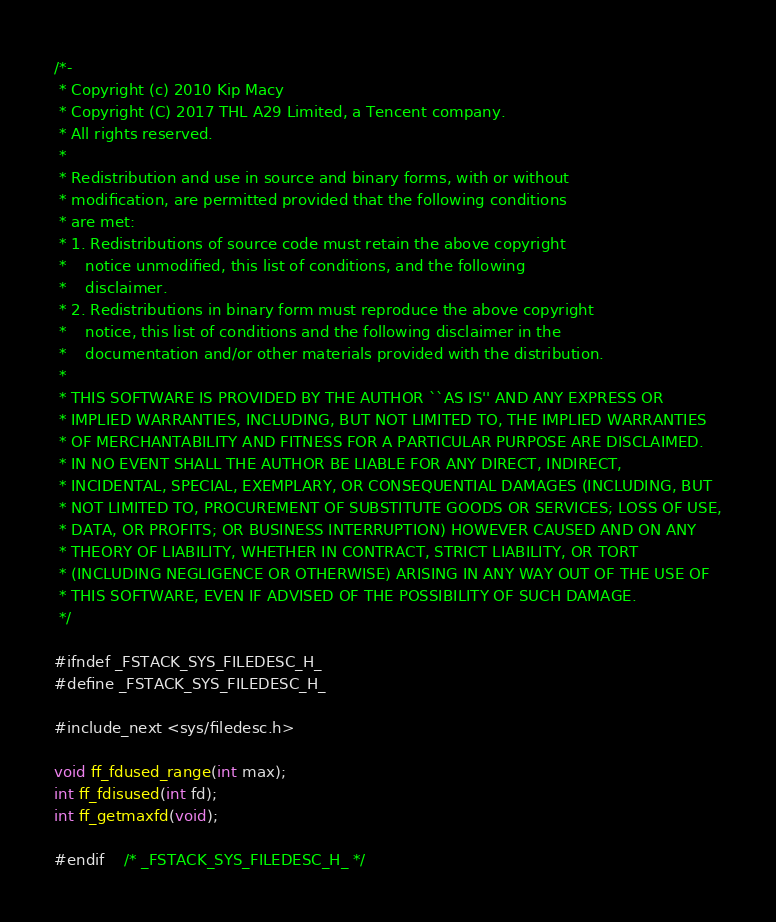Convert code to text. <code><loc_0><loc_0><loc_500><loc_500><_C_>/*-
 * Copyright (c) 2010 Kip Macy
 * Copyright (C) 2017 THL A29 Limited, a Tencent company.
 * All rights reserved.
 *
 * Redistribution and use in source and binary forms, with or without
 * modification, are permitted provided that the following conditions
 * are met:
 * 1. Redistributions of source code must retain the above copyright
 *    notice unmodified, this list of conditions, and the following
 *    disclaimer.
 * 2. Redistributions in binary form must reproduce the above copyright
 *    notice, this list of conditions and the following disclaimer in the
 *    documentation and/or other materials provided with the distribution.
 *
 * THIS SOFTWARE IS PROVIDED BY THE AUTHOR ``AS IS'' AND ANY EXPRESS OR
 * IMPLIED WARRANTIES, INCLUDING, BUT NOT LIMITED TO, THE IMPLIED WARRANTIES
 * OF MERCHANTABILITY AND FITNESS FOR A PARTICULAR PURPOSE ARE DISCLAIMED.
 * IN NO EVENT SHALL THE AUTHOR BE LIABLE FOR ANY DIRECT, INDIRECT,
 * INCIDENTAL, SPECIAL, EXEMPLARY, OR CONSEQUENTIAL DAMAGES (INCLUDING, BUT
 * NOT LIMITED TO, PROCUREMENT OF SUBSTITUTE GOODS OR SERVICES; LOSS OF USE,
 * DATA, OR PROFITS; OR BUSINESS INTERRUPTION) HOWEVER CAUSED AND ON ANY
 * THEORY OF LIABILITY, WHETHER IN CONTRACT, STRICT LIABILITY, OR TORT
 * (INCLUDING NEGLIGENCE OR OTHERWISE) ARISING IN ANY WAY OUT OF THE USE OF
 * THIS SOFTWARE, EVEN IF ADVISED OF THE POSSIBILITY OF SUCH DAMAGE.
 */

#ifndef _FSTACK_SYS_FILEDESC_H_
#define _FSTACK_SYS_FILEDESC_H_

#include_next <sys/filedesc.h>

void ff_fdused_range(int max);
int ff_fdisused(int fd);
int ff_getmaxfd(void);

#endif    /* _FSTACK_SYS_FILEDESC_H_ */
</code> 